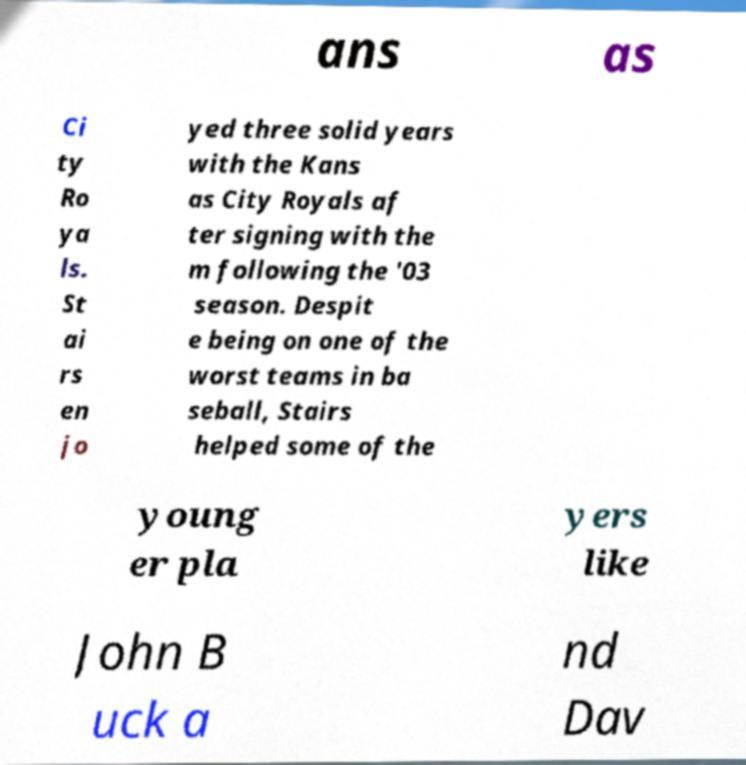Can you read and provide the text displayed in the image?This photo seems to have some interesting text. Can you extract and type it out for me? ans as Ci ty Ro ya ls. St ai rs en jo yed three solid years with the Kans as City Royals af ter signing with the m following the '03 season. Despit e being on one of the worst teams in ba seball, Stairs helped some of the young er pla yers like John B uck a nd Dav 